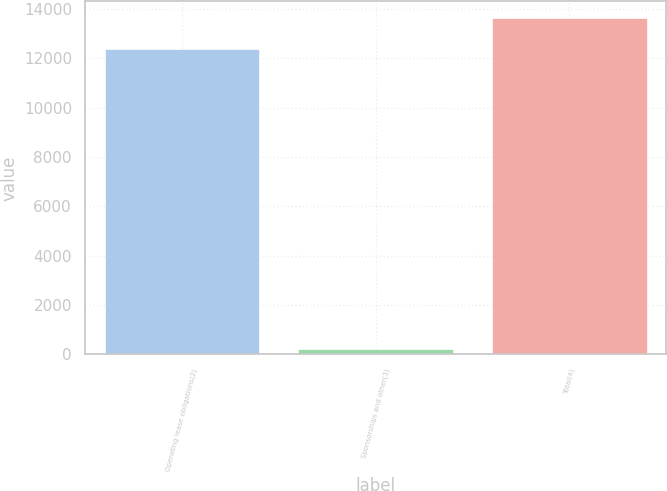<chart> <loc_0><loc_0><loc_500><loc_500><bar_chart><fcel>Operating lease obligations(2)<fcel>Sponsorships and other(3)<fcel>Total(4)<nl><fcel>12385<fcel>203<fcel>13623.5<nl></chart> 